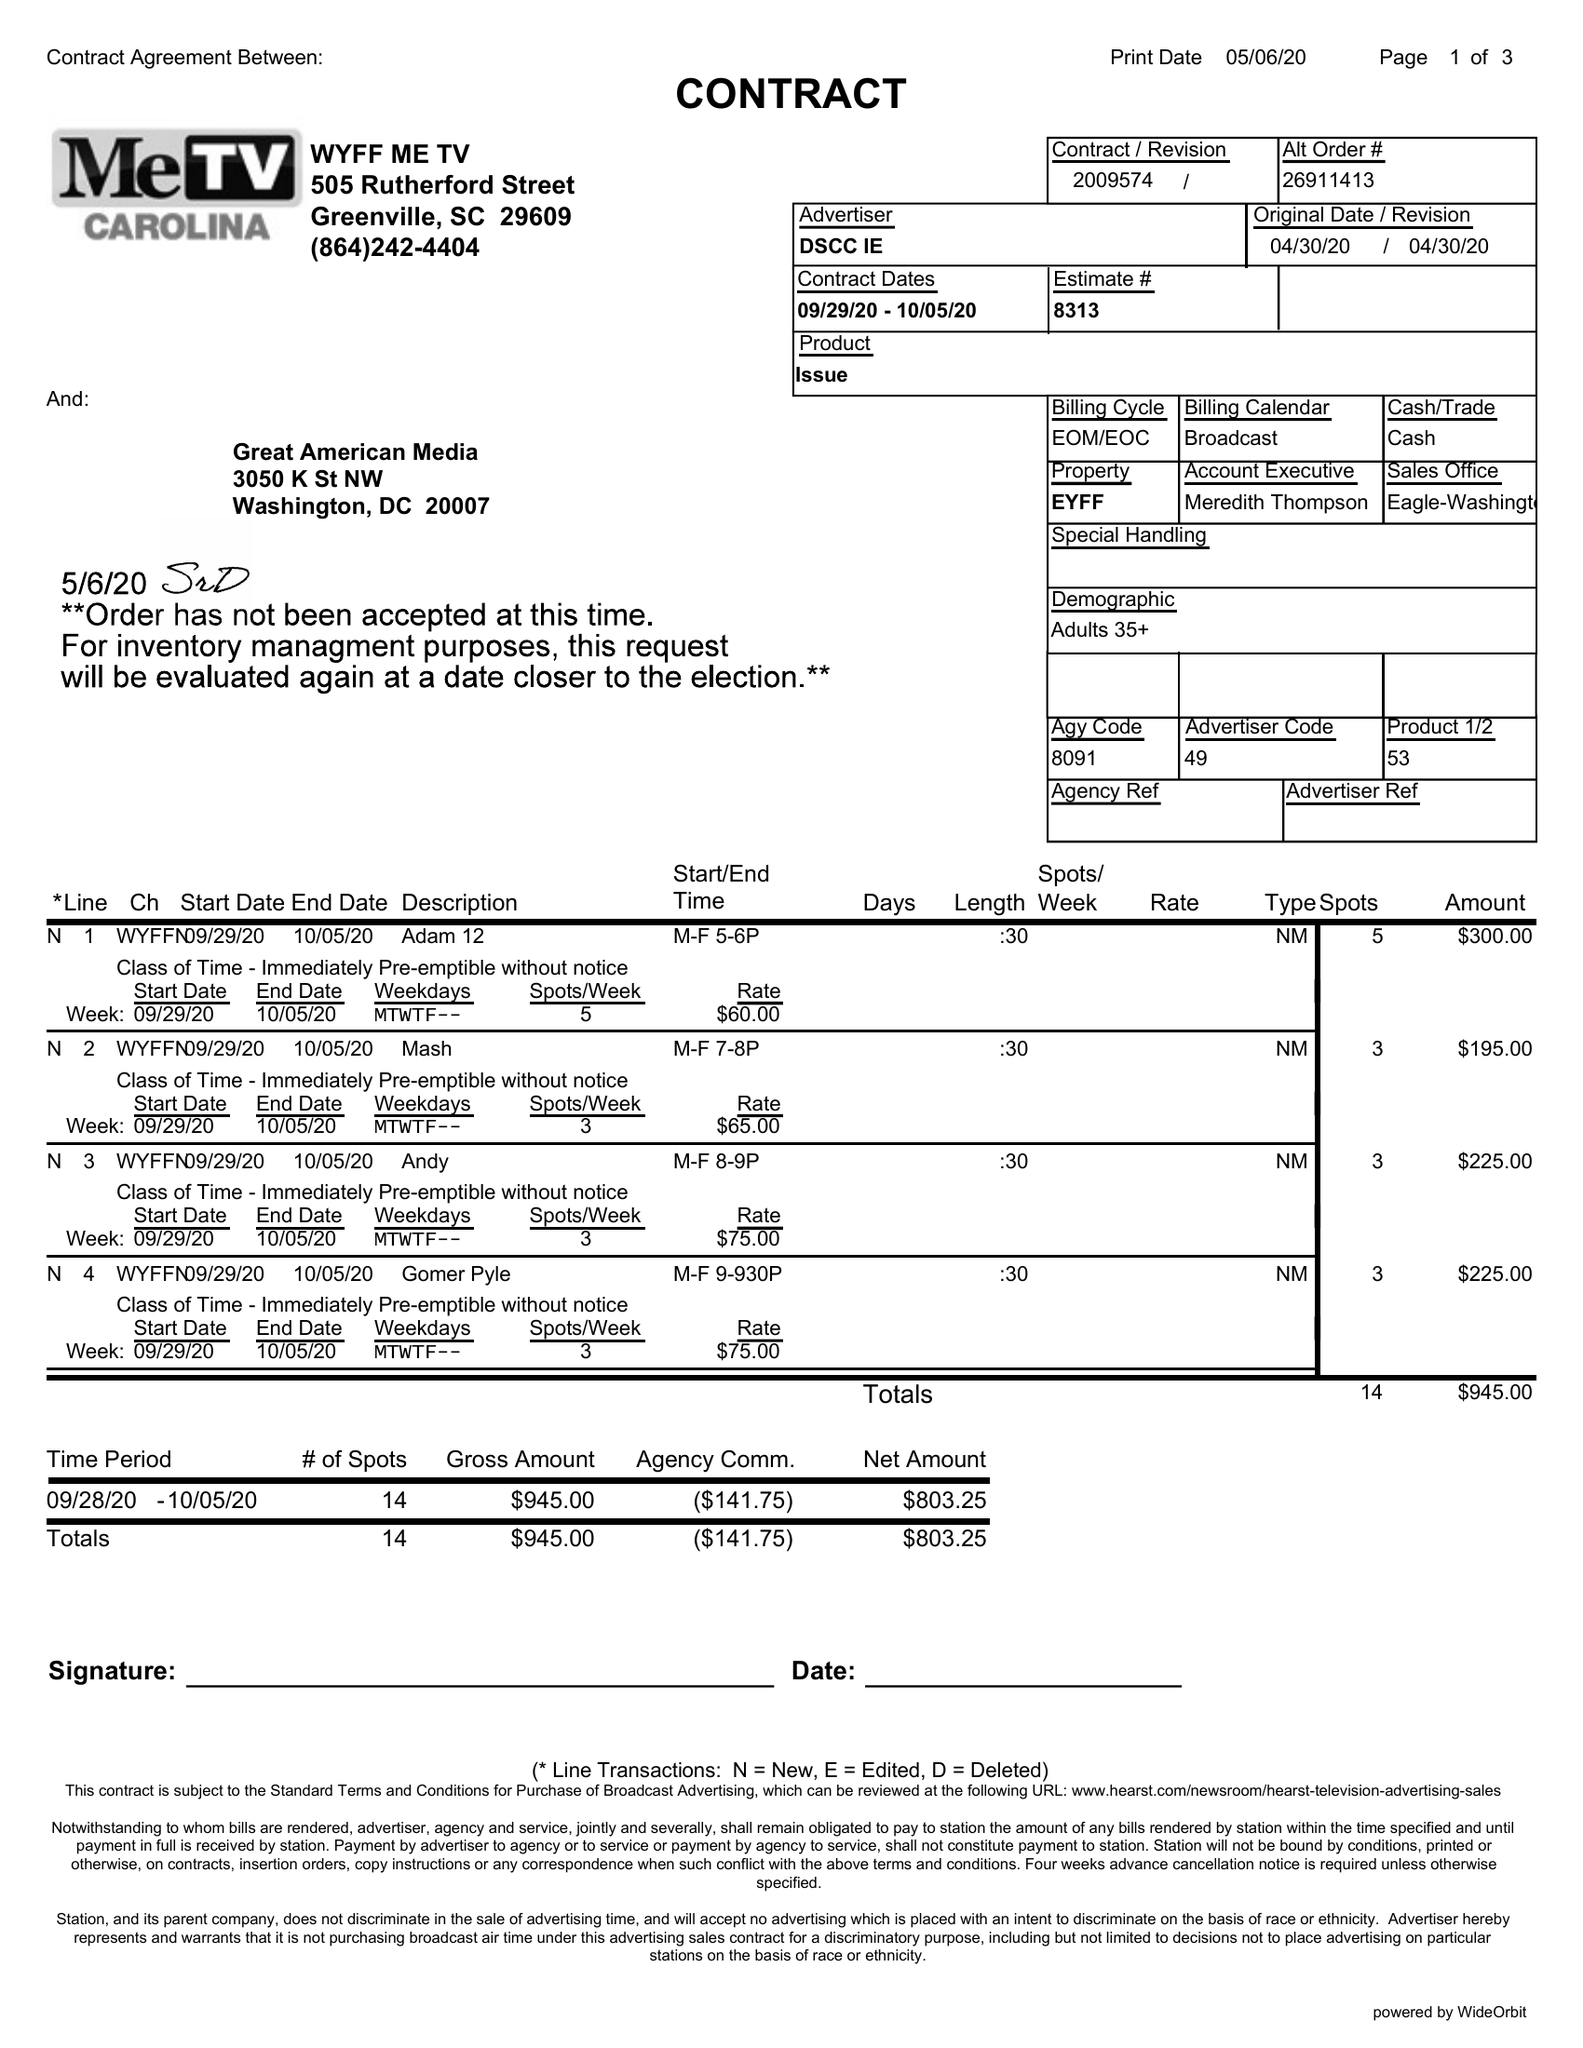What is the value for the gross_amount?
Answer the question using a single word or phrase. 945.00 